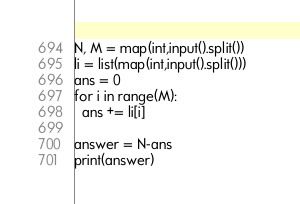Convert code to text. <code><loc_0><loc_0><loc_500><loc_500><_Python_>N, M = map(int,input().split())
li = list(map(int,input().split()))	
ans = 0
for i in range(M):
  ans += li[i]
  
answer = N-ans
print(answer)</code> 